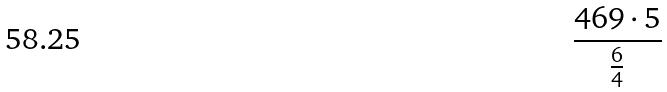<formula> <loc_0><loc_0><loc_500><loc_500>\frac { 4 6 9 \cdot 5 } { \frac { 6 } { 4 } }</formula> 